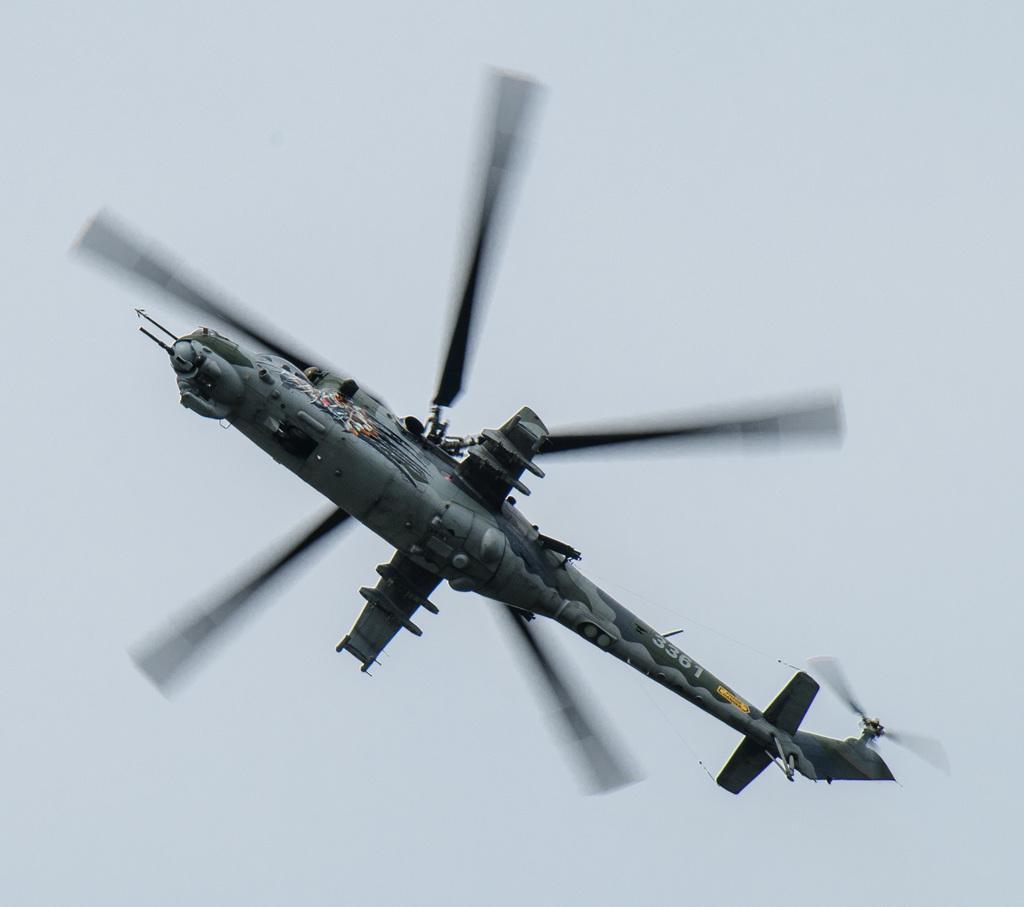How would you summarize this image in a sentence or two? In the image I can see a helicopter is flying in the air. In the background I can see the sky. 